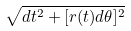<formula> <loc_0><loc_0><loc_500><loc_500>\sqrt { d t ^ { 2 } + [ r ( t ) d \theta ] ^ { 2 } }</formula> 